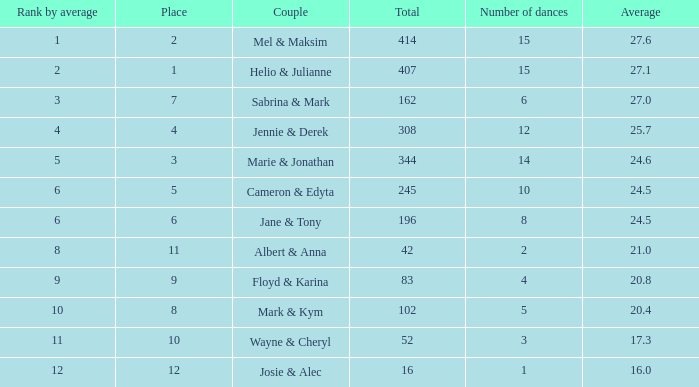What is the rank by average where the total was larger than 245 and the average was 27.1 with fewer than 15 dances? None. 